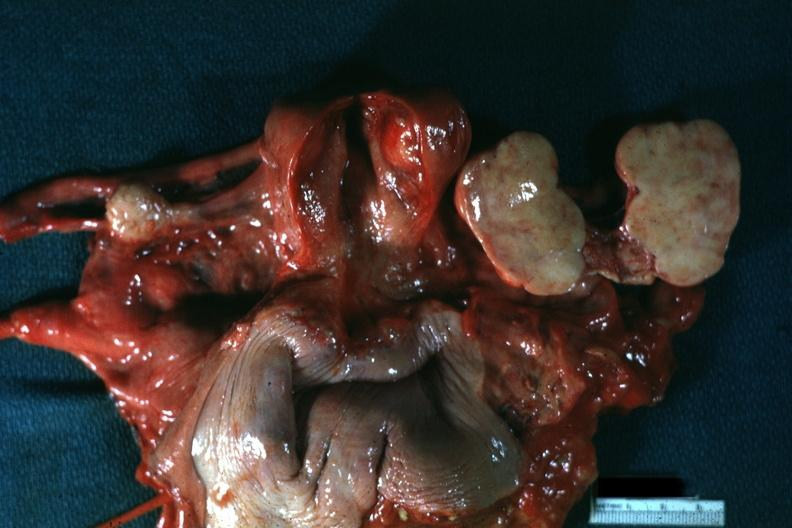s ovary present?
Answer the question using a single word or phrase. Yes 